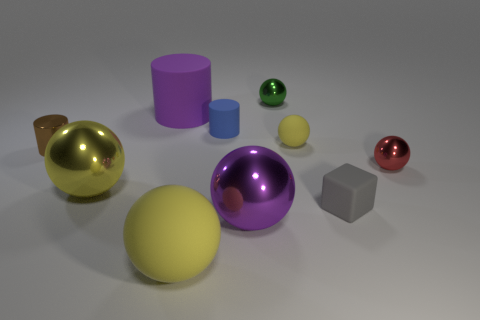There is a yellow thing that is both in front of the red thing and to the right of the yellow metallic ball; what material is it?
Provide a succinct answer. Rubber. Is the size of the shiny object to the right of the green metal ball the same as the tiny yellow rubber object?
Provide a succinct answer. Yes. What is the material of the red object?
Provide a short and direct response. Metal. What is the color of the small shiny thing behind the tiny brown object?
Make the answer very short. Green. What number of small objects are shiny cylinders or purple rubber cylinders?
Your answer should be very brief. 1. Is the color of the large shiny sphere that is behind the large purple metal object the same as the small sphere that is behind the small yellow object?
Give a very brief answer. No. How many other things are the same color as the metal cylinder?
Your answer should be compact. 0. What number of yellow things are rubber things or large matte things?
Give a very brief answer. 2. Do the green object and the big yellow matte thing in front of the tiny brown thing have the same shape?
Offer a very short reply. Yes. The tiny yellow matte object has what shape?
Ensure brevity in your answer.  Sphere. 